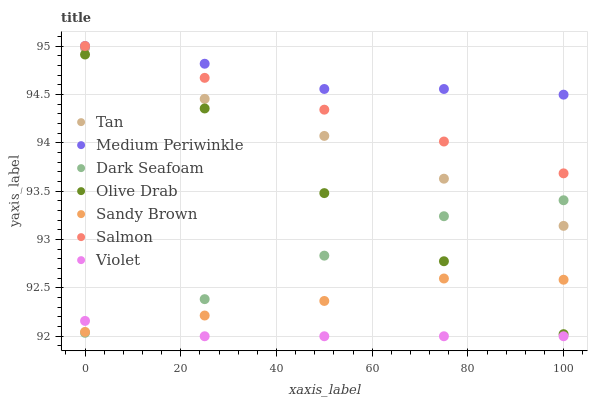Does Violet have the minimum area under the curve?
Answer yes or no. Yes. Does Medium Periwinkle have the maximum area under the curve?
Answer yes or no. Yes. Does Dark Seafoam have the minimum area under the curve?
Answer yes or no. No. Does Dark Seafoam have the maximum area under the curve?
Answer yes or no. No. Is Salmon the smoothest?
Answer yes or no. Yes. Is Olive Drab the roughest?
Answer yes or no. Yes. Is Medium Periwinkle the smoothest?
Answer yes or no. No. Is Medium Periwinkle the roughest?
Answer yes or no. No. Does Violet have the lowest value?
Answer yes or no. Yes. Does Dark Seafoam have the lowest value?
Answer yes or no. No. Does Medium Periwinkle have the highest value?
Answer yes or no. Yes. Does Dark Seafoam have the highest value?
Answer yes or no. No. Is Olive Drab less than Tan?
Answer yes or no. Yes. Is Salmon greater than Olive Drab?
Answer yes or no. Yes. Does Dark Seafoam intersect Olive Drab?
Answer yes or no. Yes. Is Dark Seafoam less than Olive Drab?
Answer yes or no. No. Is Dark Seafoam greater than Olive Drab?
Answer yes or no. No. Does Olive Drab intersect Tan?
Answer yes or no. No. 